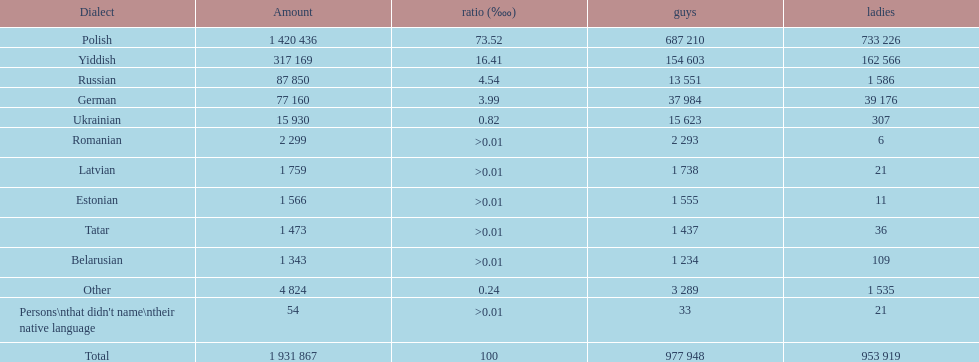How many languages are shown? Polish, Yiddish, Russian, German, Ukrainian, Romanian, Latvian, Estonian, Tatar, Belarusian, Other. What language is in third place? Russian. What language is the most spoken after that one? German. 